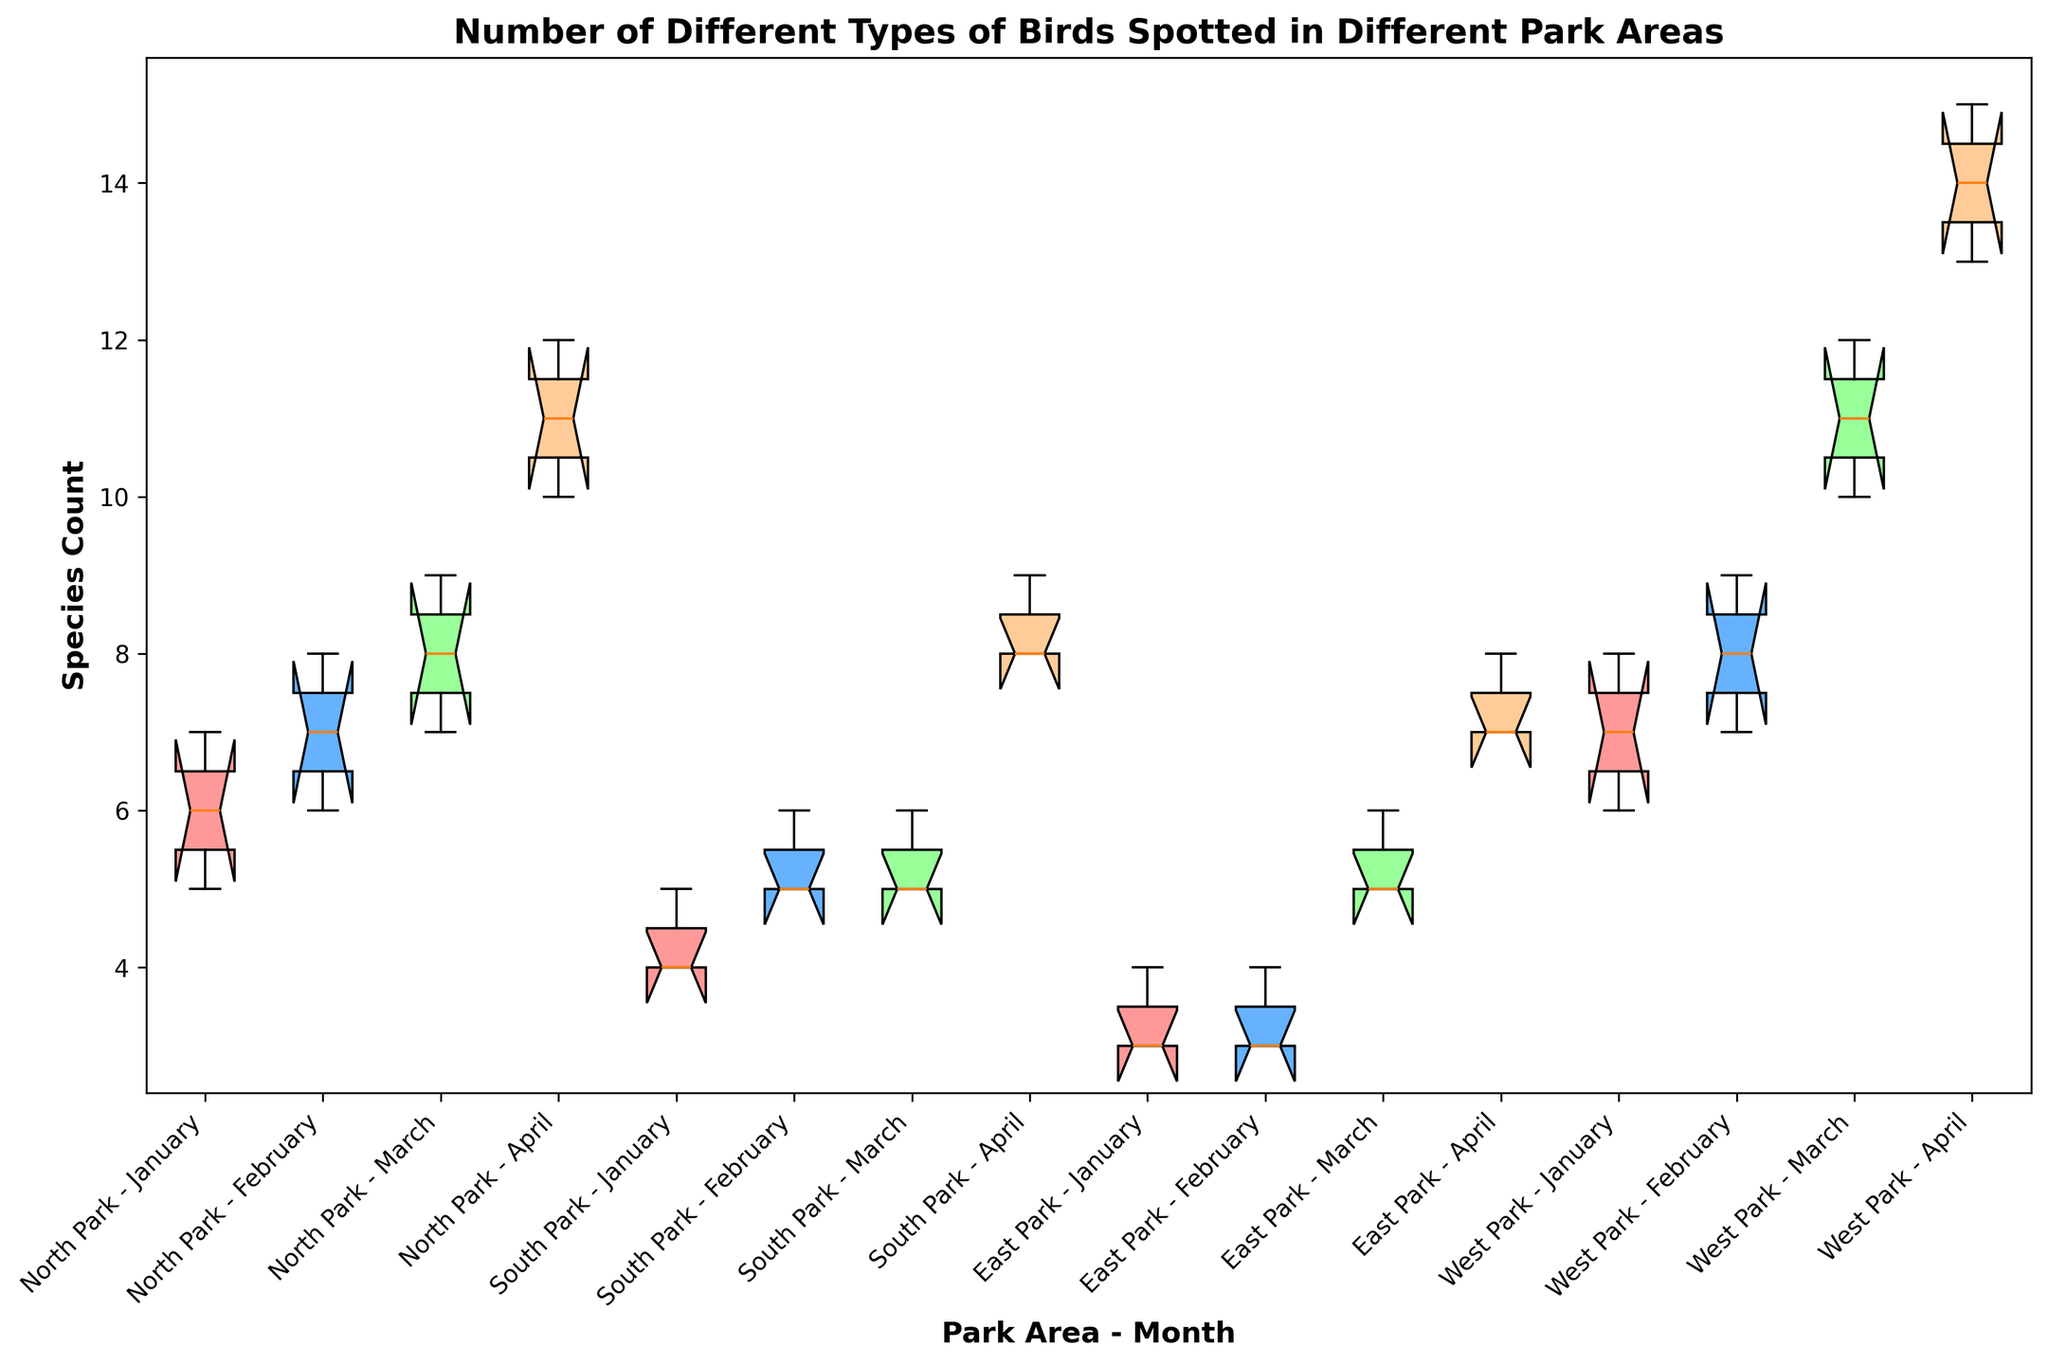Which park area had the highest median species count in April? To answer this, look at the positions of the median lines inside the boxes for each park area during April. The highest median line will indicate the park area with the highest median count.
Answer: West Park What is the interquartile range (IQR) of bird species in North Park during January? The IQR is found by subtracting the value at the first quartile (bottom of the box) from the value at the third quartile (top of the box) for the specific park area and month.
Answer: 2 (7 - 5) Which park area had the most consistent species count in February? The most consistent (least variation) can be inferred from the smallest box height (range between first and third quartile) for February across the park areas.
Answer: East Park Compare the species count variability in March between North Park and South Park. Which one has more variability? More variability is indicated by a taller box. To determine this, compare the heights of the boxes for North Park and South Park in March.
Answer: North Park What is the median species count for South Park in March? Find the median line (middle line inside the box) for South Park in March and read its value.
Answer: 5 Which park area showed the biggest increase in median species count from January to April? Compare the median lines of each park area in January and April. The largest vertical difference indicates the biggest increase.
Answer: West Park How does the spread of species count in East Park compare between January and April? Check the white space in the boxes (range between first and third quartile) for East Park in January and April. The wider the box, the larger the spread.
Answer: Larger in April In which month did North Park have the highest maximum species count? Look at the top whisker (upper line extending from the box) for North Park across all months and identify which one extends the highest.
Answer: April What can you infer about the species count in South Park in January versus February? Compare the boxes for South Park in January and February. Note the median lines and the heights of the boxes.
Answer: Slight increase in February Which park area had the lowest minimum species count in January? Look for the lowest whisker (bottom line extending from the box) in January for all park areas. The lowest one indicates the minimum species count.
Answer: East Park 